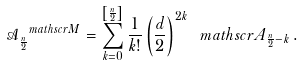Convert formula to latex. <formula><loc_0><loc_0><loc_500><loc_500>\mathcal { A } ^ { \ m a t h s c r { M } } _ { \frac { n } { 2 } } = \sum _ { k = 0 } ^ { \left [ \frac { n } { 2 } \right ] } \frac { 1 } { k ! } \left ( \frac { d } { 2 } \right ) ^ { 2 k } \ m a t h s c r { A } _ { \frac { n } { 2 } - k } \, .</formula> 